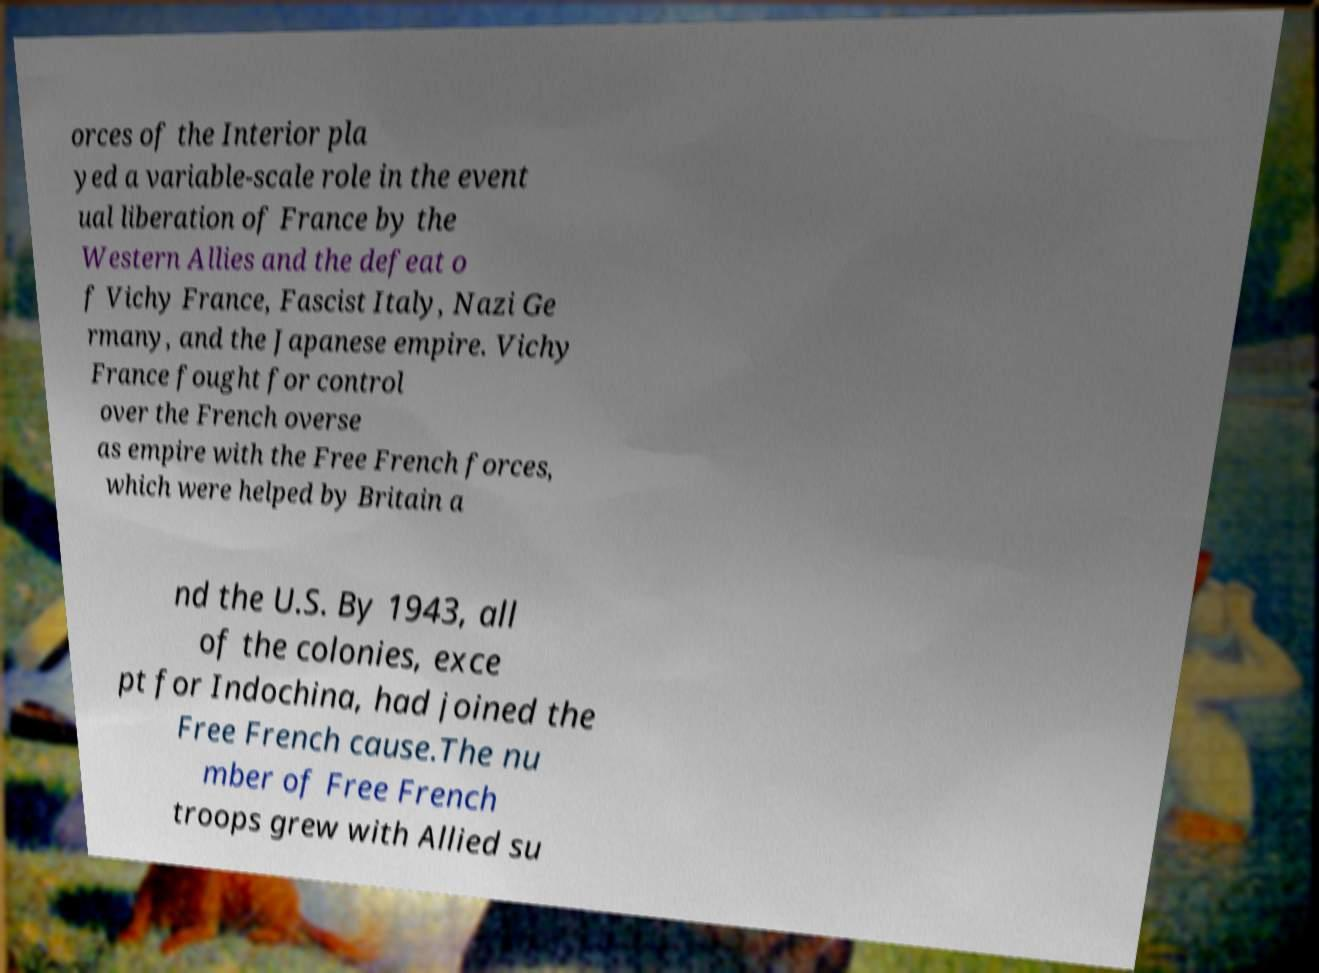Could you assist in decoding the text presented in this image and type it out clearly? orces of the Interior pla yed a variable-scale role in the event ual liberation of France by the Western Allies and the defeat o f Vichy France, Fascist Italy, Nazi Ge rmany, and the Japanese empire. Vichy France fought for control over the French overse as empire with the Free French forces, which were helped by Britain a nd the U.S. By 1943, all of the colonies, exce pt for Indochina, had joined the Free French cause.The nu mber of Free French troops grew with Allied su 